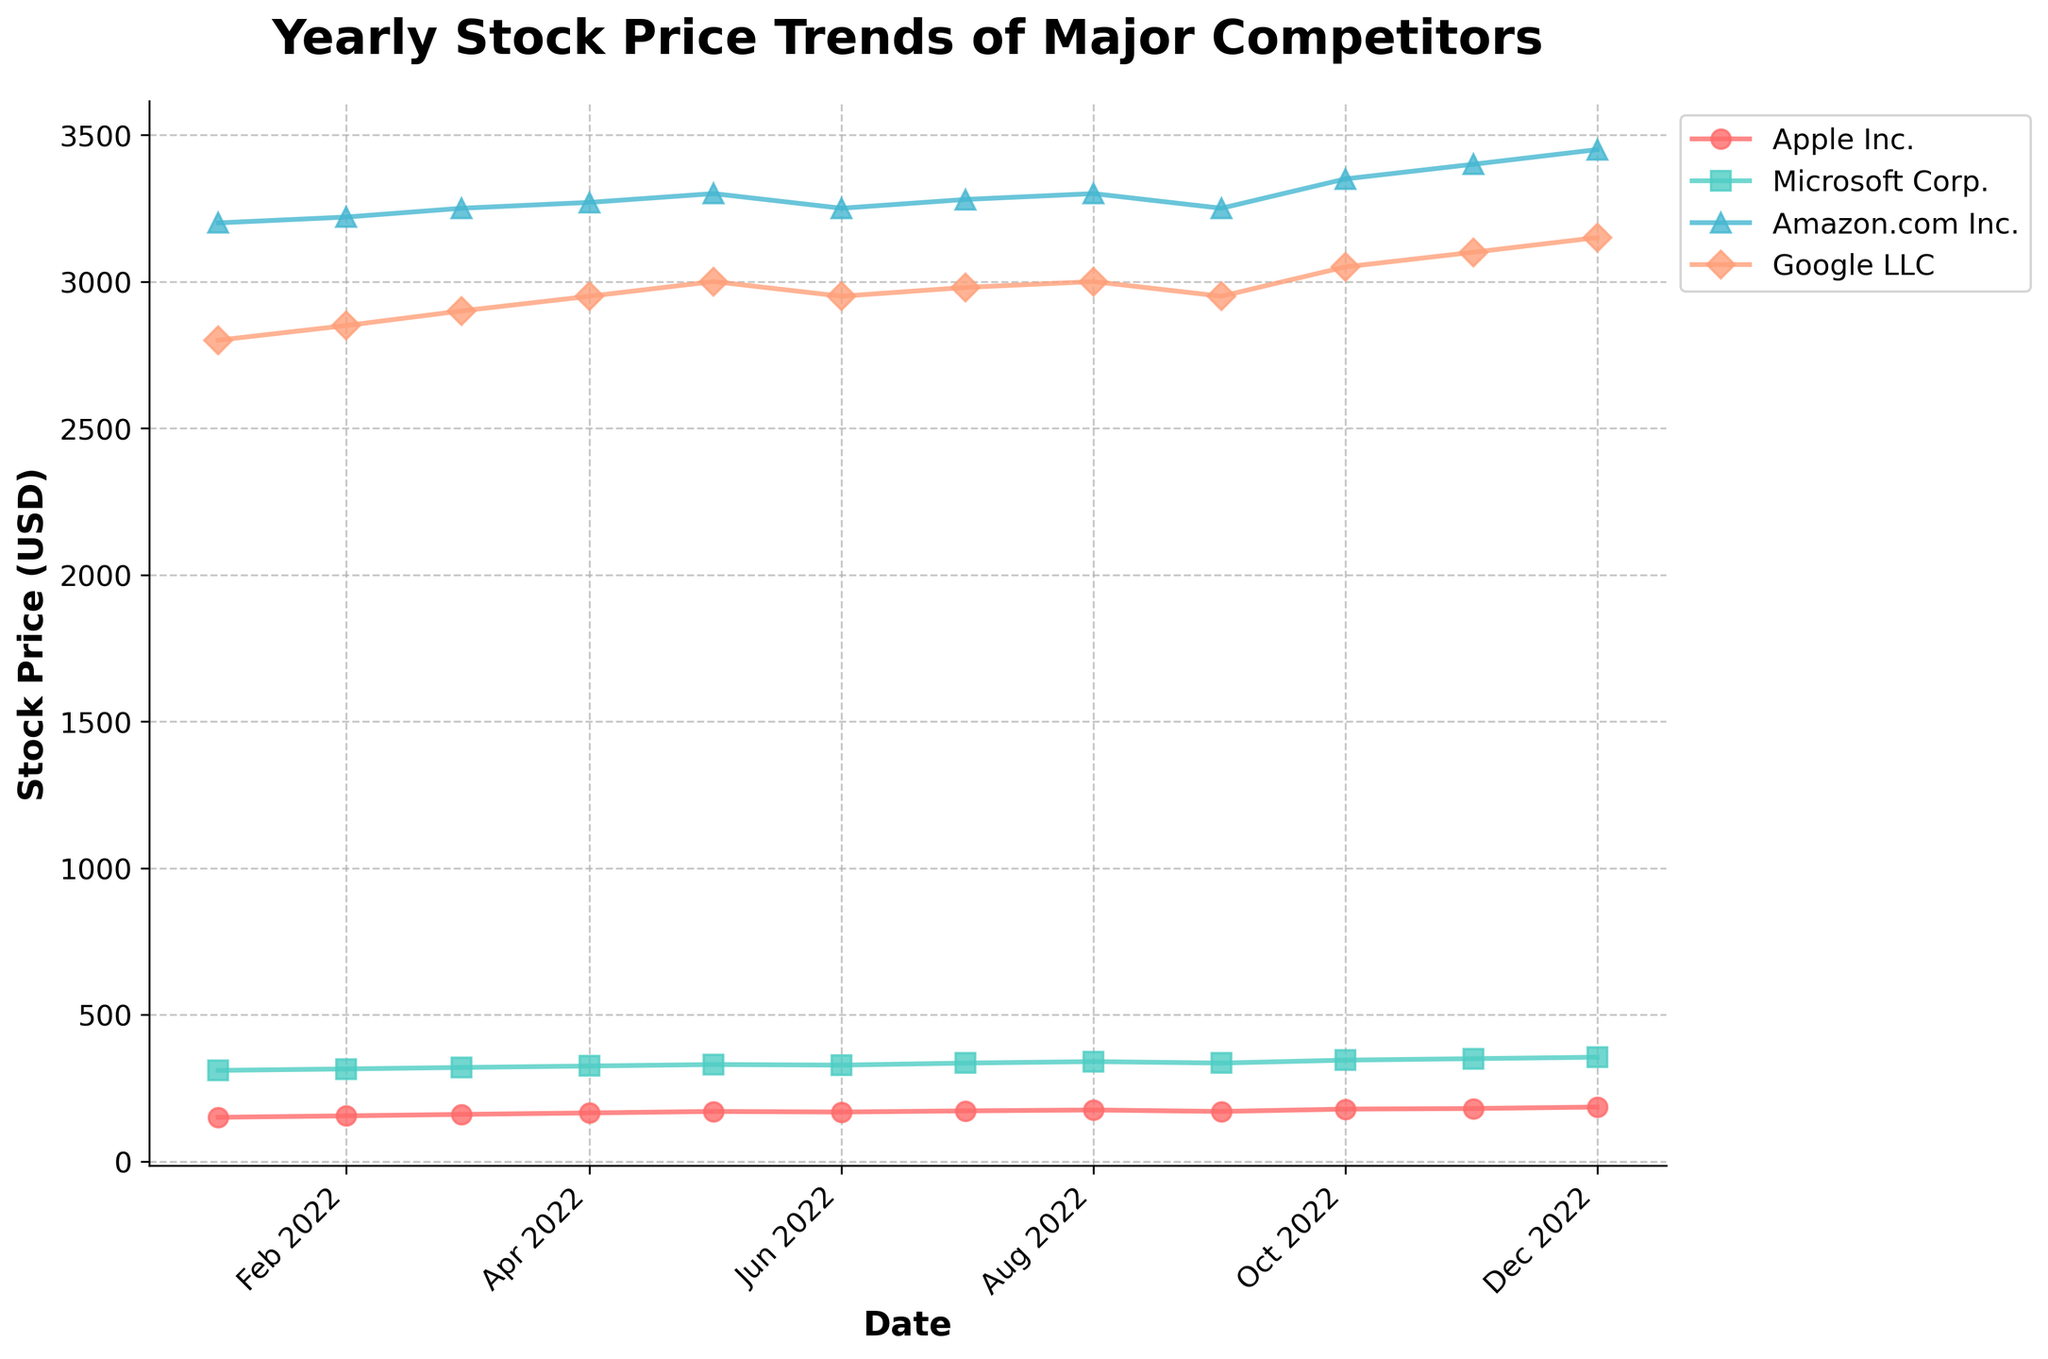What is the title of the plot? The title of the plot is written at the top and it states "Yearly Stock Price Trends of Major Competitors".
Answer: Yearly Stock Price Trends of Major Competitors Which company had the highest stock price at the start of 2022? By looking at the stock prices at the beginning of 2022 (January 1st), Amazon.com Inc. had the highest stock price, which was 3200.00 USD.
Answer: Amazon.com Inc What color represents Apple Inc.? The plot uses specific colors for each company, and Apple Inc. is represented by a red color line.
Answer: Red How does Microsoft Corp.'s stock price trend compare to Apple Inc.'s over the year? Microsoft Corp.'s stock price starts higher than Apple Inc.'s and increases more consistently over the year, whereas Apple Inc. has some fluctuations but also shows an overall increase.
Answer: Microsoft Corp.'s stock price is higher and more consistent During which month did Google LLC's stock price first reach 3000 USD? Observing the plot, Google LLC’s stock price first reached 3000 USD in May 2022.
Answer: May 2022 What was the stock price trend for Amazon.com Inc. in June 2022? Amazon.com Inc.'s stock price decreased from 3300.00 USD in May to 3250.00 USD in June, indicating a downward trend for that month.
Answer: Downward Which company showed the greatest increase in stock price from January to December 2022? By comparing the stock prices of each company from January to December 2022, Microsoft Corp. showed the most significant increase from 310.00 USD to 355.00 USD, which is a 45 USD increase.
Answer: Microsoft Corp Between which months did Apple Inc. experience a dip in stock price? Apple Inc. experienced a dip in its stock price between May 2022 (170.00 USD) and June 2022 (168.00 USD).
Answer: May and June By how much did Google LLC's stock price increase from October to November? Google LLC's stock price increased from 3050.00 USD (October) to 3100.00 USD (November), an increase of 50.00 USD.
Answer: 50.00 USD Which company had the most stable stock price through the year? By observing the fluctuation of all companies' stock prices, Amazon.com Inc. had relatively stable prices with minor rises and dips compared to the other companies.
Answer: Amazon.com Inc 